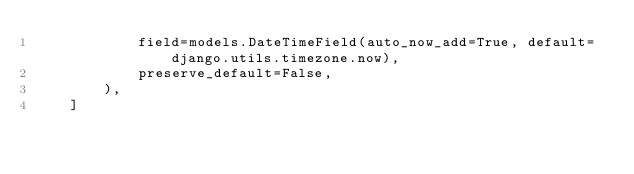Convert code to text. <code><loc_0><loc_0><loc_500><loc_500><_Python_>            field=models.DateTimeField(auto_now_add=True, default=django.utils.timezone.now),
            preserve_default=False,
        ),
    ]
</code> 